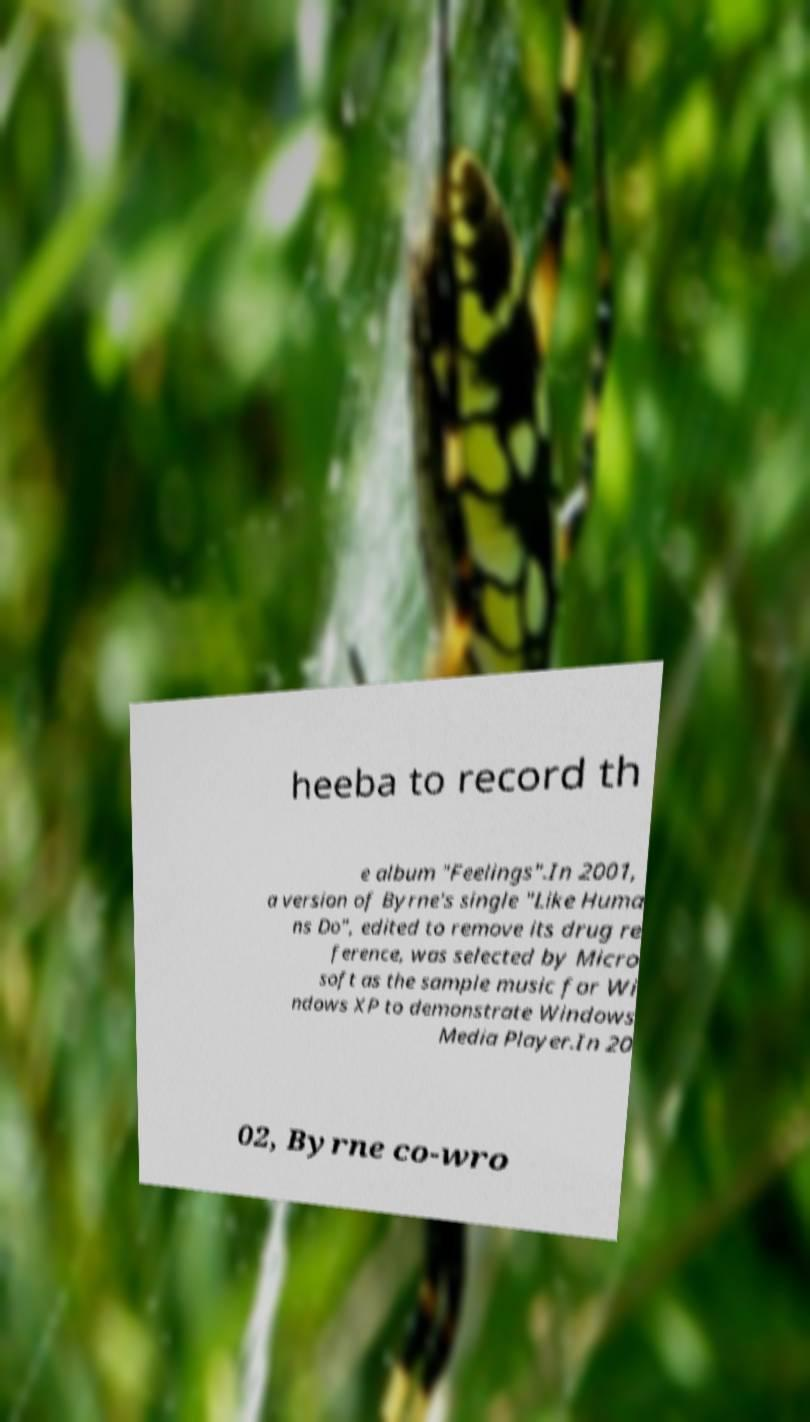What messages or text are displayed in this image? I need them in a readable, typed format. heeba to record th e album "Feelings".In 2001, a version of Byrne's single "Like Huma ns Do", edited to remove its drug re ference, was selected by Micro soft as the sample music for Wi ndows XP to demonstrate Windows Media Player.In 20 02, Byrne co-wro 